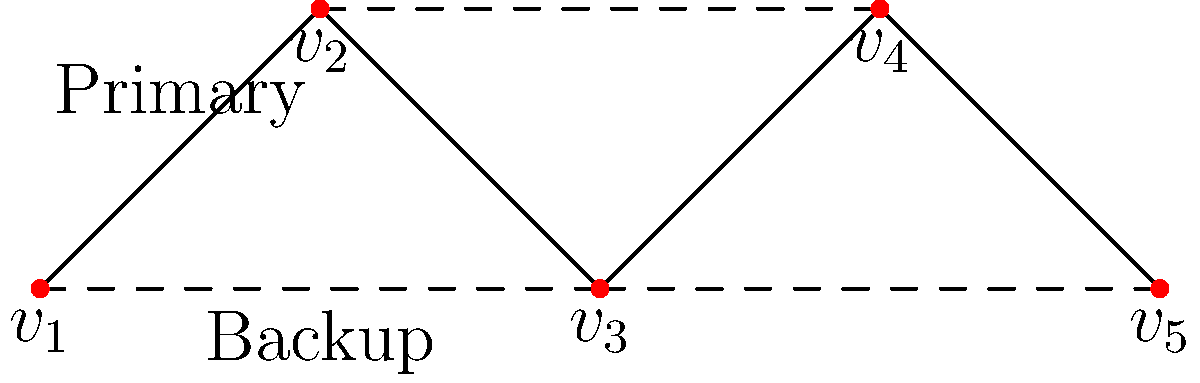In a war-torn region, a communication network is represented by the graph above. Solid lines indicate primary connections, while dashed lines represent backup routes. If the primary connection between $v_2$ and $v_3$ is destroyed, what is the minimum number of edges that need to be removed to completely disconnect $v_1$ from $v_5$? To solve this problem, we need to follow these steps:

1. Identify the initial state of the network:
   - The primary connection between $v_2$ and $v_3$ is already destroyed.
   - We need to find the minimum number of edges to disconnect $v_1$ from $v_5$.

2. Analyze the remaining paths from $v_1$ to $v_5$:
   - Path 1: $v_1 - v_2 - v_4 - v_5$
   - Path 2: $v_1 - v_2 - v_5$
   - Path 3: $v_1 - v_3 - v_4 - v_5$

3. Determine the minimum cut:
   - To disconnect $v_1$ from $v_5$, we need to remove at least one edge from each path.
   - The edge $v_2 - v_4$ is common to paths 1 and 3.
   - Removing $v_2 - v_4$ and $v_2 - v_5$ will disconnect all paths.

4. Count the minimum number of edges to be removed:
   - We need to remove 2 edges: $v_2 - v_4$ and $v_2 - v_5$.

Therefore, the minimum number of edges that need to be removed to completely disconnect $v_1$ from $v_5$ is 2.
Answer: 2 